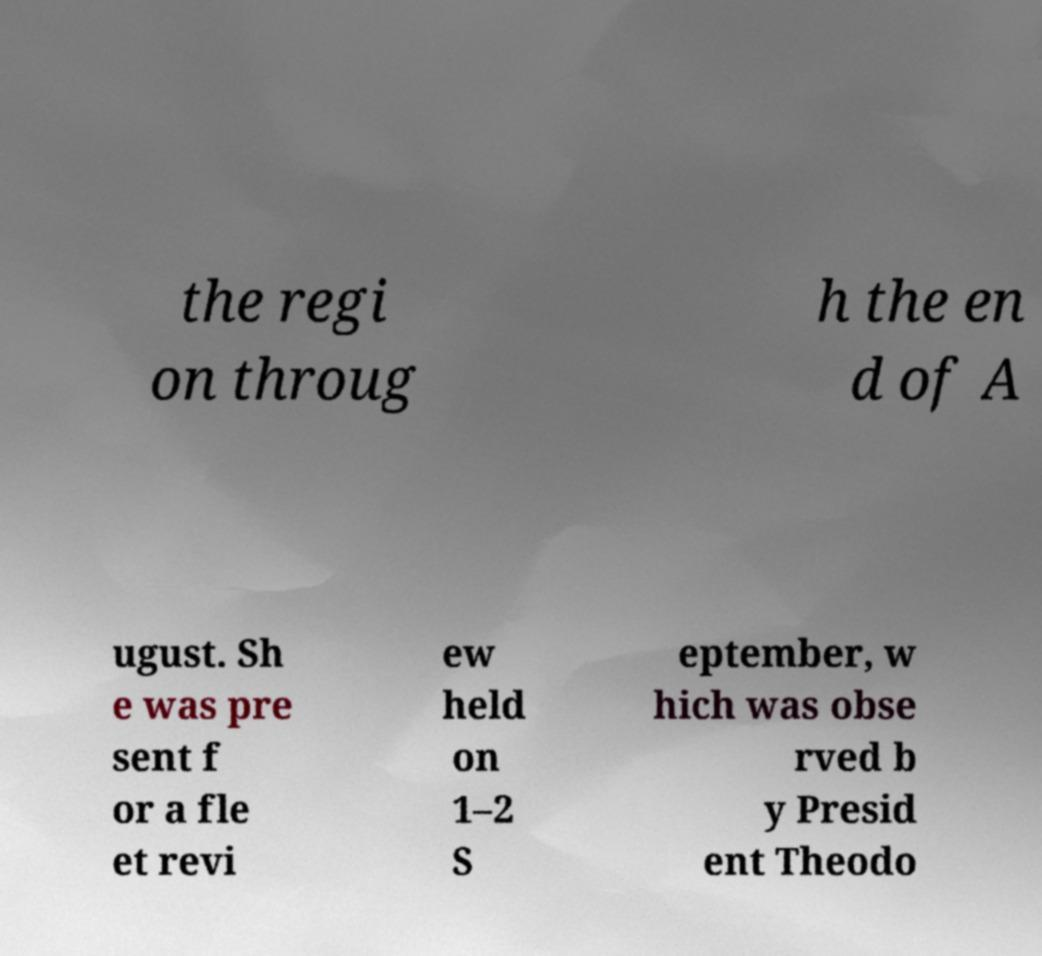Please identify and transcribe the text found in this image. the regi on throug h the en d of A ugust. Sh e was pre sent f or a fle et revi ew held on 1–2 S eptember, w hich was obse rved b y Presid ent Theodo 